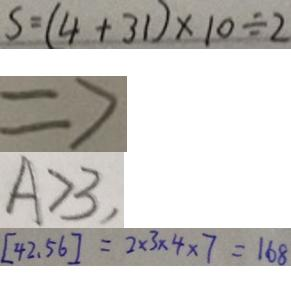Convert formula to latex. <formula><loc_0><loc_0><loc_500><loc_500>S = ( 4 + 3 1 ) \times 1 0 \div 2 
 \Rightarrow 
 A > 3 , 
 [ 4 2 , 5 6 ] = 2 \times 3 \times 4 \times 7 = 1 6 8</formula> 